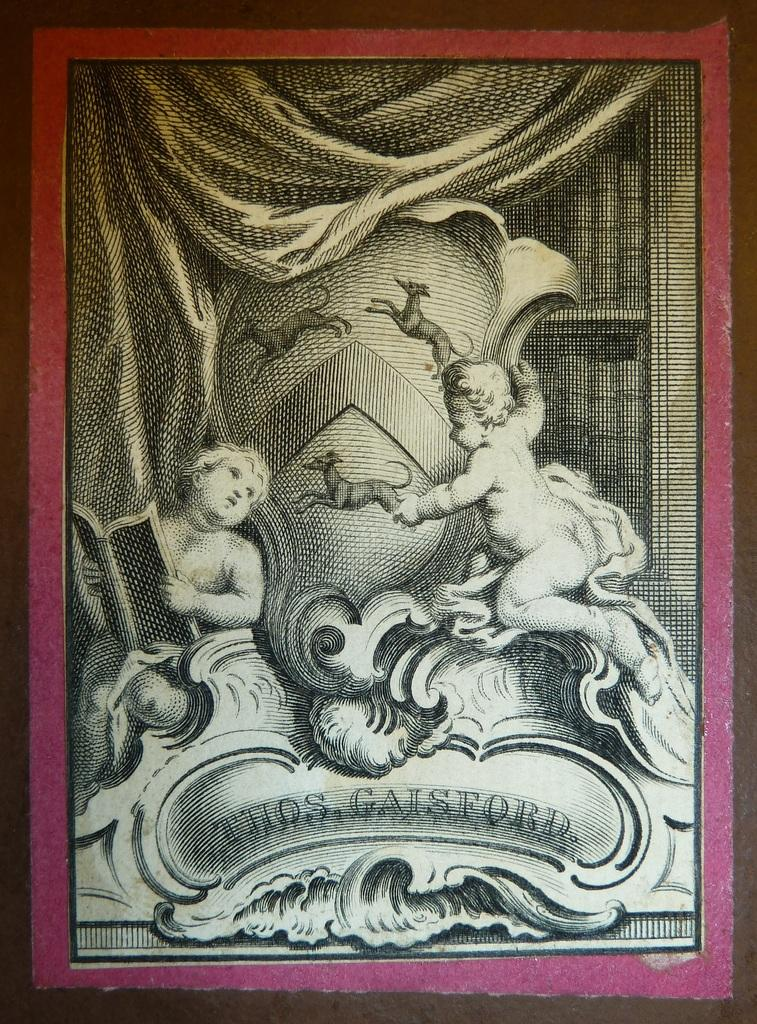What is the main subject of the image? There is an art piece in the image. What does the art piece depict? The art piece depicts two babies. Where are the babies situated in the art piece? The babies are sitting on a bed. What is visible behind the bed in the art piece? There is a curtain behind the bed. What type of territory is being claimed by the snakes in the image? There are no snakes present in the image; it features an art piece depicting two babies sitting on a bed. What type of authority figure is depicted in the image? There is no authority figure depicted in the image; it features an art piece with two babies sitting on a bed. 